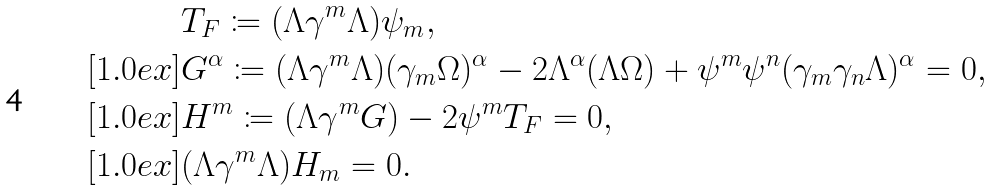Convert formula to latex. <formula><loc_0><loc_0><loc_500><loc_500>& T _ { F } \coloneqq ( \Lambda \gamma ^ { m } \Lambda ) \psi _ { m } , \\ [ 1 . 0 e x ] & G ^ { \alpha } \coloneqq ( \Lambda \gamma ^ { m } \Lambda ) ( \gamma _ { m } \Omega ) ^ { \alpha } - 2 \Lambda ^ { \alpha } ( \Lambda \Omega ) + \psi ^ { m } \psi ^ { n } ( \gamma _ { m } \gamma _ { n } \Lambda ) ^ { \alpha } = 0 , \\ [ 1 . 0 e x ] & H ^ { m } \coloneqq ( \Lambda \gamma ^ { m } G ) - 2 \psi ^ { m } T _ { F } = 0 , \\ [ 1 . 0 e x ] & ( \Lambda \gamma ^ { m } \Lambda ) H _ { m } = 0 .</formula> 